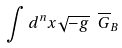<formula> <loc_0><loc_0><loc_500><loc_500>\int d ^ { n } x \sqrt { - g } \ \overline { G } _ { B }</formula> 